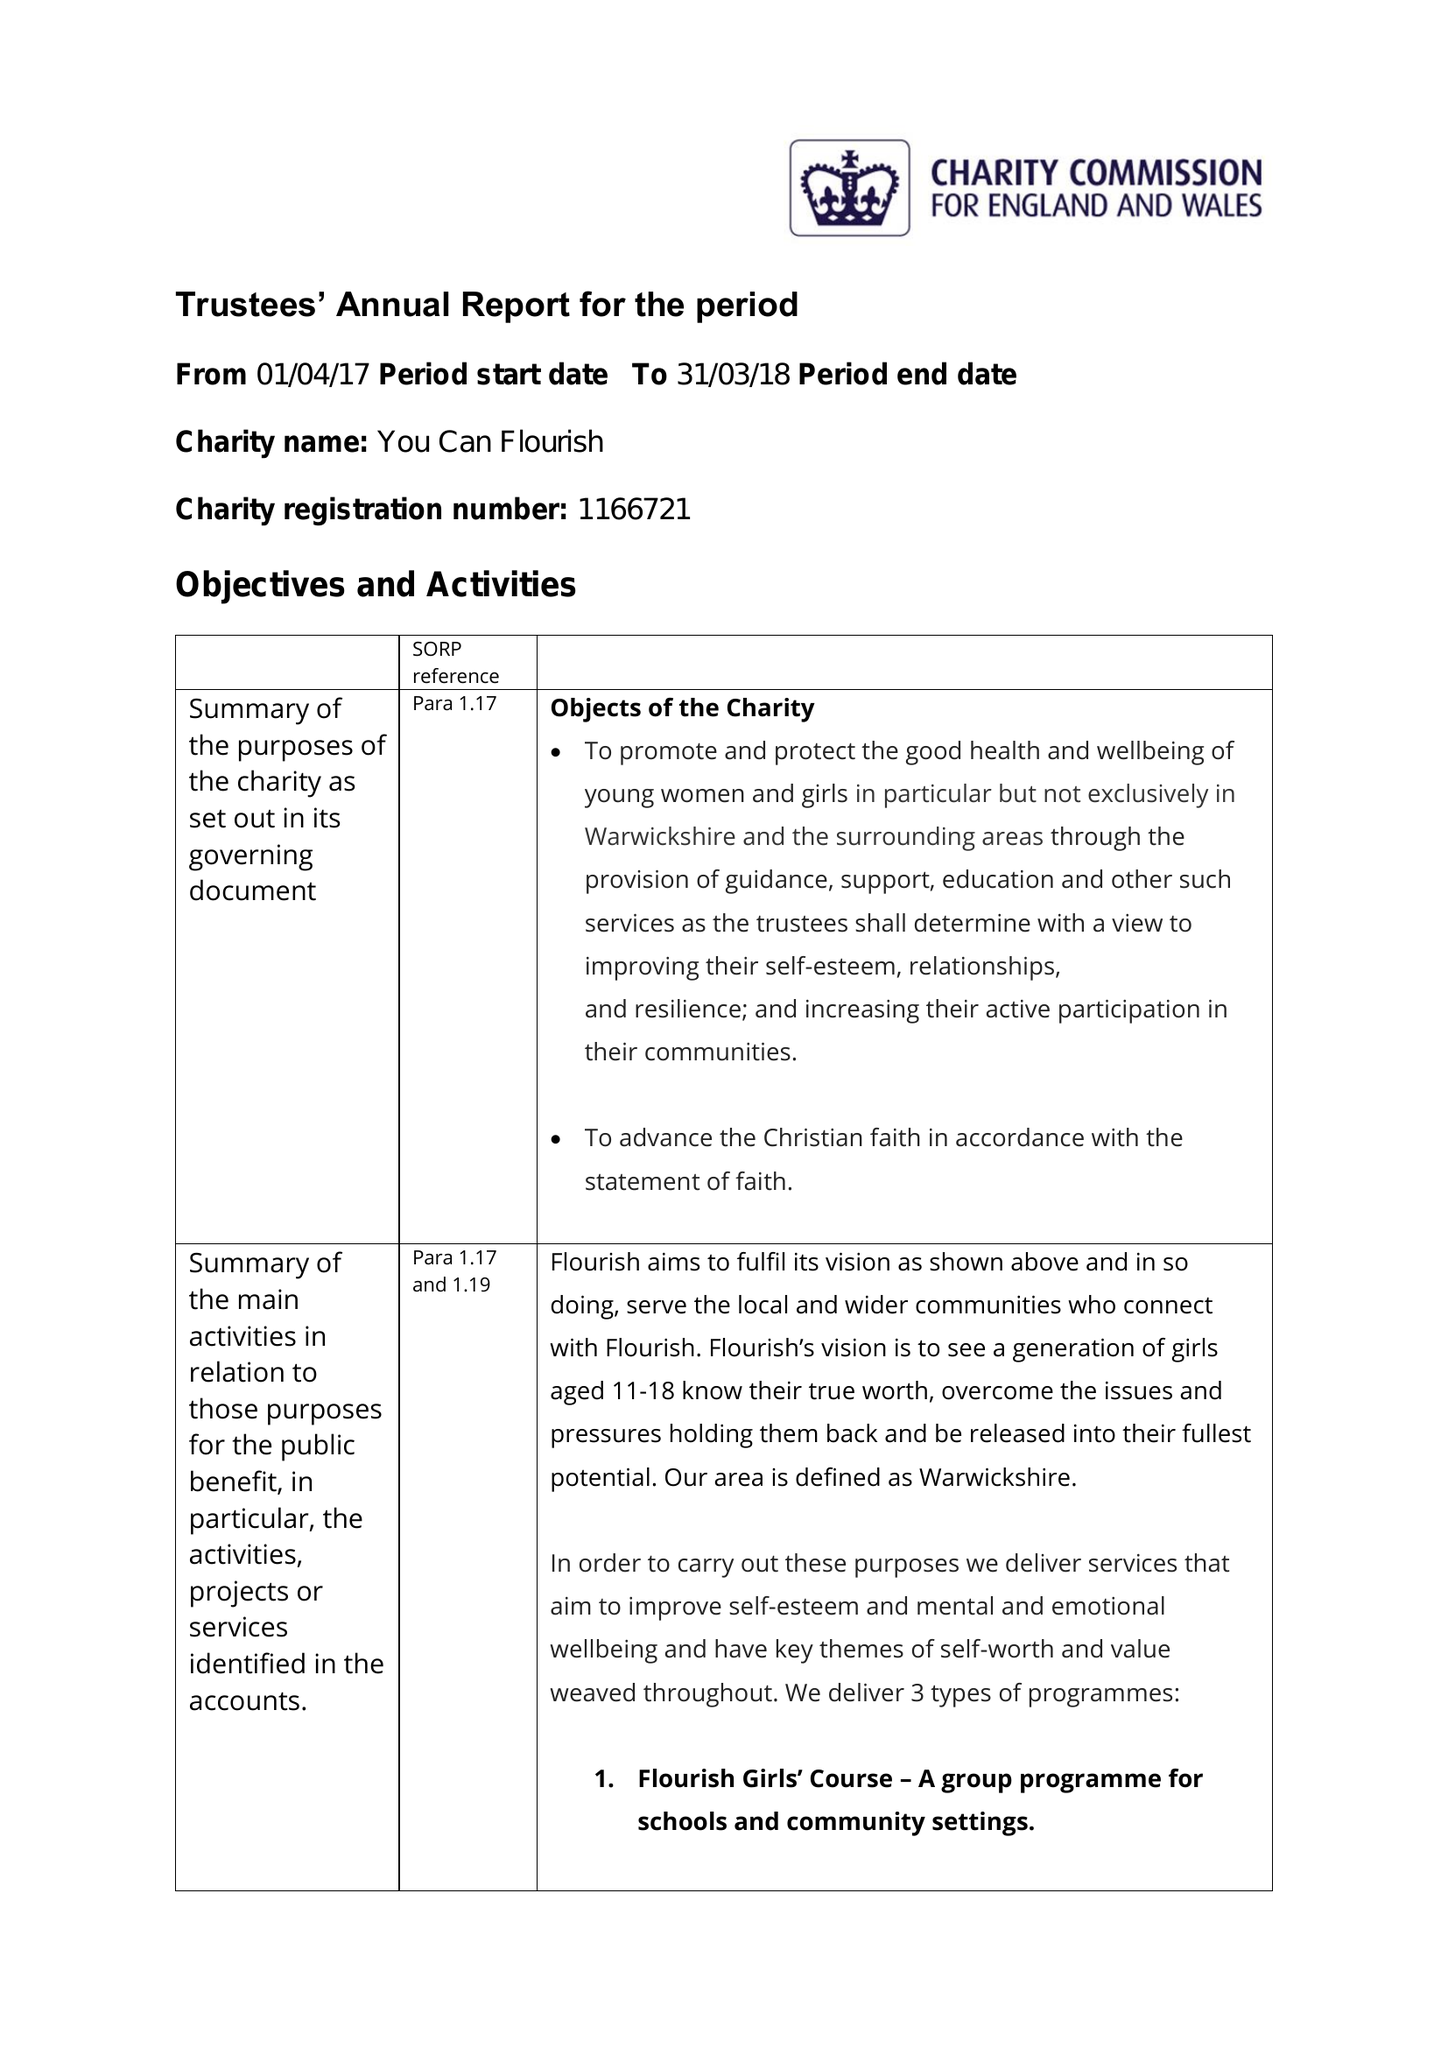What is the value for the income_annually_in_british_pounds?
Answer the question using a single word or phrase. 25835.00 